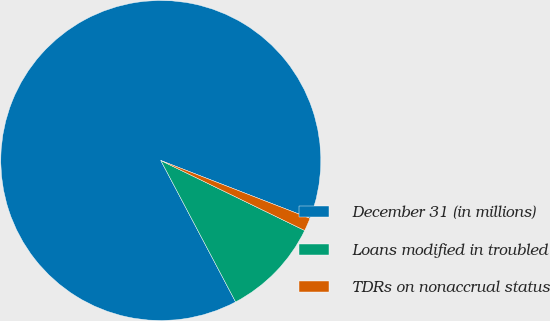Convert chart to OTSL. <chart><loc_0><loc_0><loc_500><loc_500><pie_chart><fcel>December 31 (in millions)<fcel>Loans modified in troubled<fcel>TDRs on nonaccrual status<nl><fcel>88.62%<fcel>10.05%<fcel>1.32%<nl></chart> 